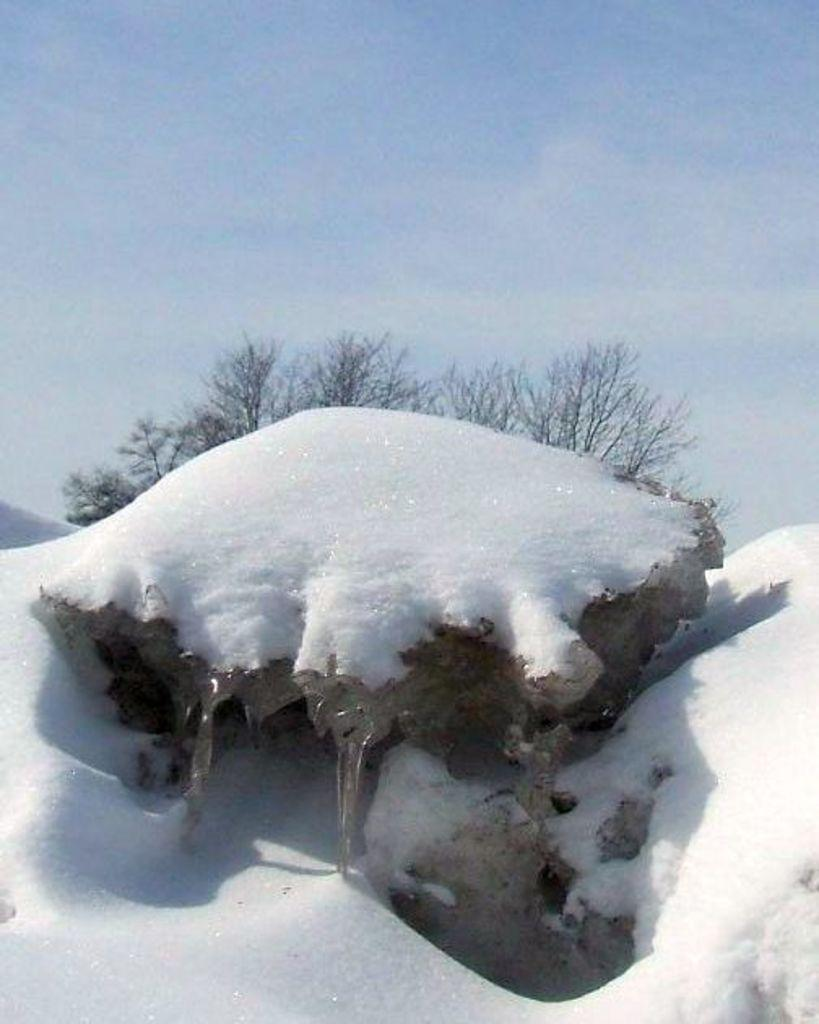What is the main subject of the image? The main subject of the image is a rock. What is covering the rock in the image? The rock is covered with snow. What can be seen in the background of the image? There are trees and the sky visible in the background of the image. Where is the quicksand located in the image? There is no quicksand present in the image. What type of flame can be seen coming from the trees in the image? There are no flames present in the image; the trees are covered in snow. 